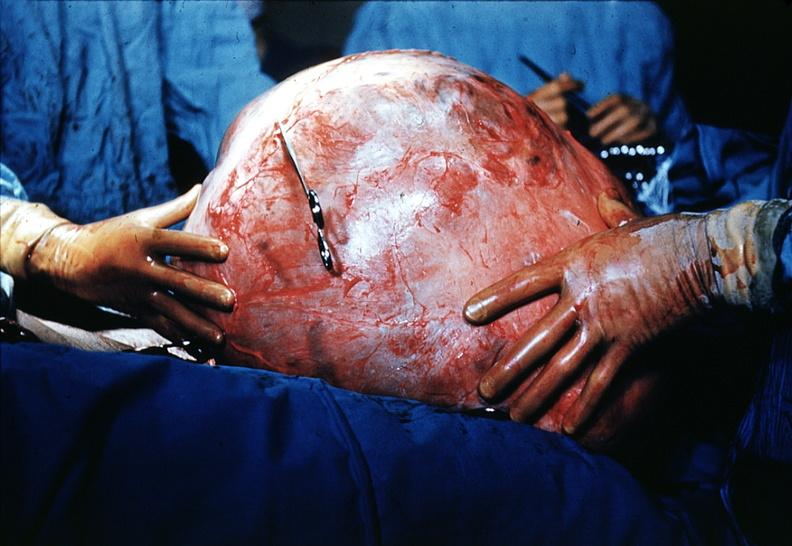what is present?
Answer the question using a single word or phrase. Female reproductive 